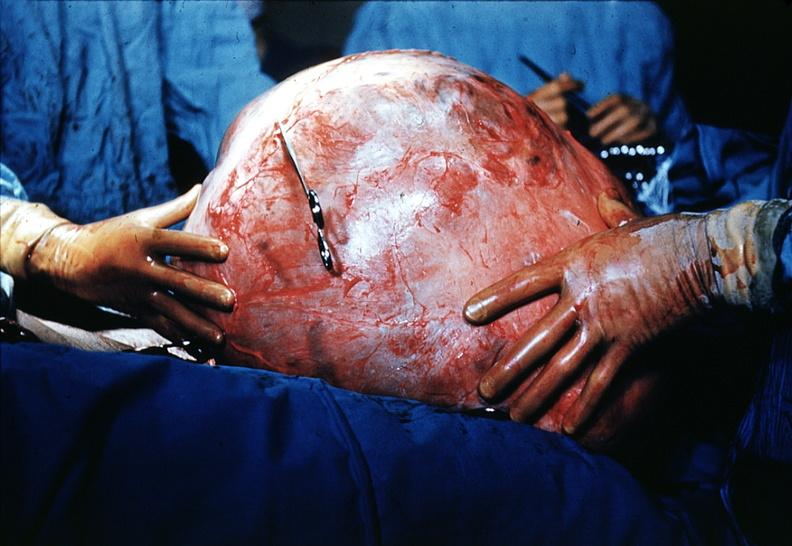what is present?
Answer the question using a single word or phrase. Female reproductive 